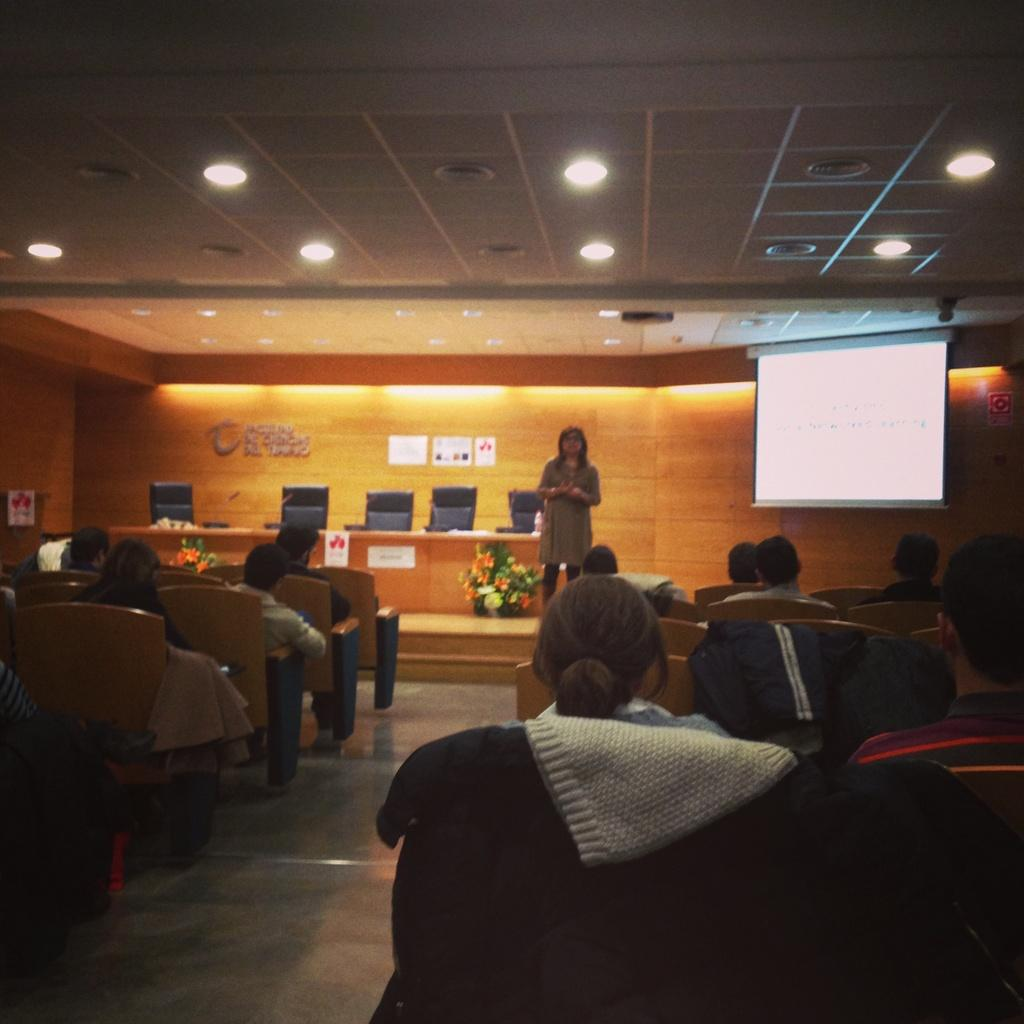What are the people in the image doing? The people in the image are sitting on chairs. Is there anyone standing in the image? Yes, there is a person standing in the image. What can be seen in the background of the image? In the background of the image, there is a wall, a screen, chairs, a table, and flowers. Are there any lights visible in the image? Yes, there are lights visible in the image. What type of surface is depicted in the image? The image depicts a floor. What type of crate is being used to hold the pie in the image? There is: There is no crate or pie present in the image. What is the person holding in their hand, and is it made of quill? There is no object made of quill visible in the person's hand in the image. 